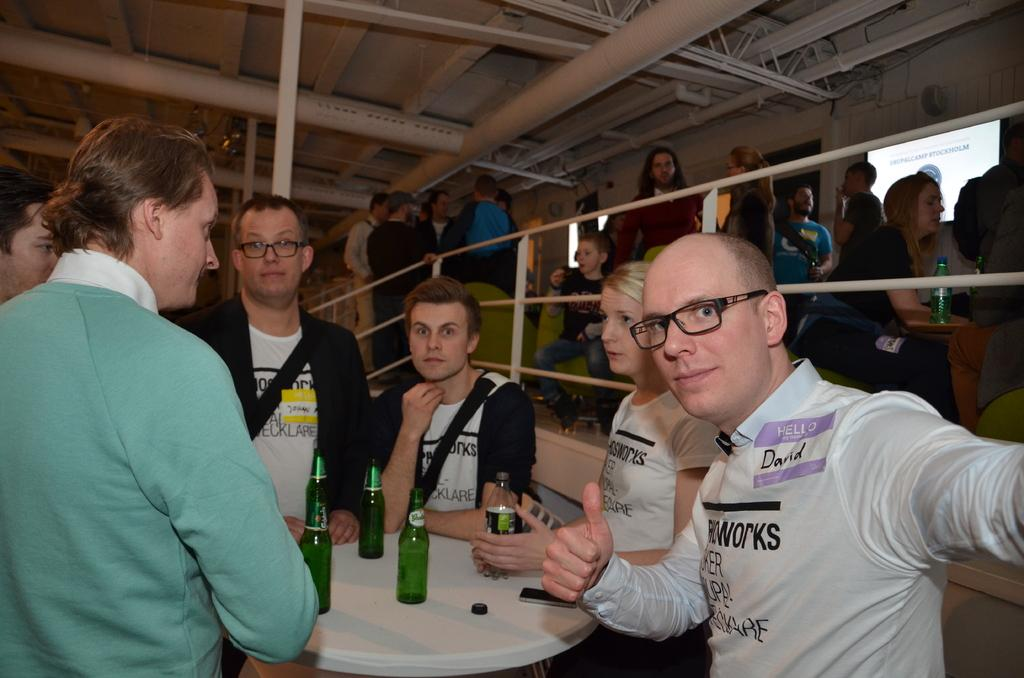How many people are in the image? There is a group of people in the image, but the exact number cannot be determined from the provided facts. What is on the table in the image? There is a bottle, a cap, and a mobile on the table in the image. What can be seen in the background of the image? In the background, there is a pillar, staircases, and a screen. What type of fang can be seen on the table in the image? There is no fang present on the table in the image. What decision is being made by the group of people in the image? The provided facts do not give any information about a decision being made by the group of people in the image. 